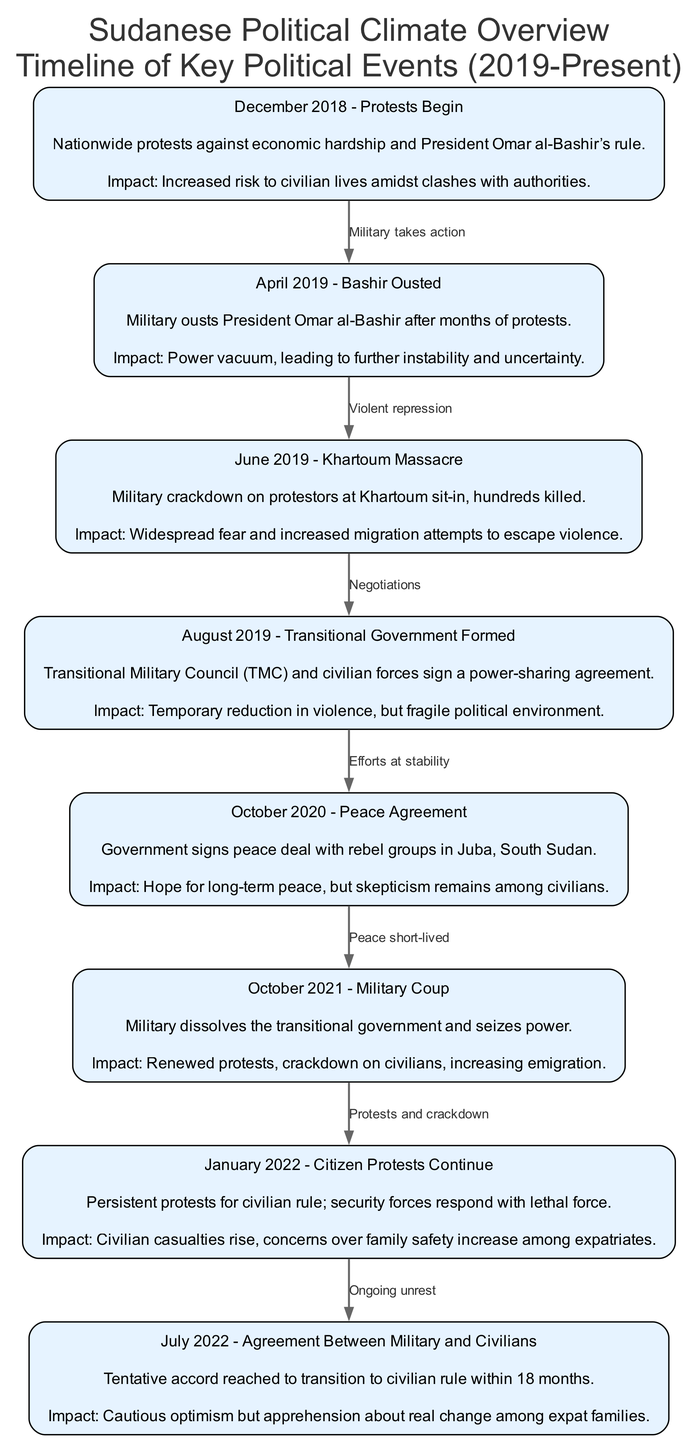What year did the protests begin in Sudan? The diagram node labeled "December 2018 - Protests Begin" indicates that protests started in December 2018. The label directly states the month and year.
Answer: December 2018 What was the impact of the June 2019 Khartoum Massacre? The "June 2019 - Khartoum Massacre" node describes that the military crackdown resulted in "widespread fear and increased migration attempts to escape violence." This information is noted under the impact section of that node.
Answer: Widespread fear and increased migration attempts How many nodes are in the diagram? By counting the number of 'nodes' listed in the data, we can determine that there are a total of eight key political events represented in the diagram. This includes each significant event since December 2018.
Answer: Eight What event occurred after the October 2020 peace agreement? The diagram illustrates that the event following the "October 2020 - Peace Agreement" node is the "October 2021 - Military Coup." The directed edge connects these two nodes and indicates the sequence of events.
Answer: October 2021 - Military Coup What is the relationship between the events in June 2019 and August 2019? The diagram shows a directed edge connecting "June 2019" to "August 2019" labeled "Negotiations." This indicates that the actions taken during the June massacre led to negotiations in August, demonstrating a cause-and-effect relationship within the timeline.
Answer: Negotiations What was the impact noted for the October 2021 Military Coup? The "October 2021 - Military Coup" node has the impact listed as "Renewed protests, crackdown on civilians, increasing emigration." This information reveals the consequences of the coup on the civilian population and migration patterns.
Answer: Renewed protests, crackdown on civilians, increasing emigration How did the situation change from January 2022 to July 2022? The transition from the "January 2022 - Citizen Protests Continue" node, which indicates rising civilian casualties and family safety concerns, to the "July 2022 - Agreement Between Military and Civilians" node, which suggests cautious optimism for change, shows a potential shift towards improvement despite ongoing unrest. The edges indicate ongoing unrest leading to a tentative agreement.
Answer: Shift from ongoing protests to cautious optimism What type of diagram is represented here? This diagram is a "Textbook Diagram," indicated by the overall structure focusing on a timeline that sequentially illustrates the key political events and their impacts on civilian safety and migration trends, typical of educational materials.
Answer: Textbook Diagram 